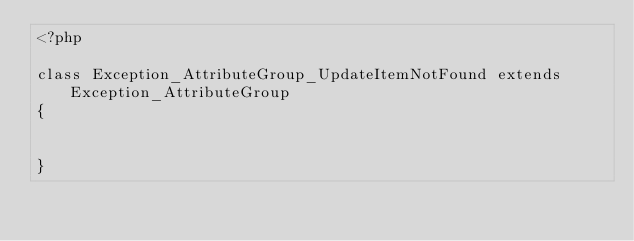Convert code to text. <code><loc_0><loc_0><loc_500><loc_500><_PHP_><?php

class Exception_AttributeGroup_UpdateItemNotFound extends Exception_AttributeGroup
{


}</code> 